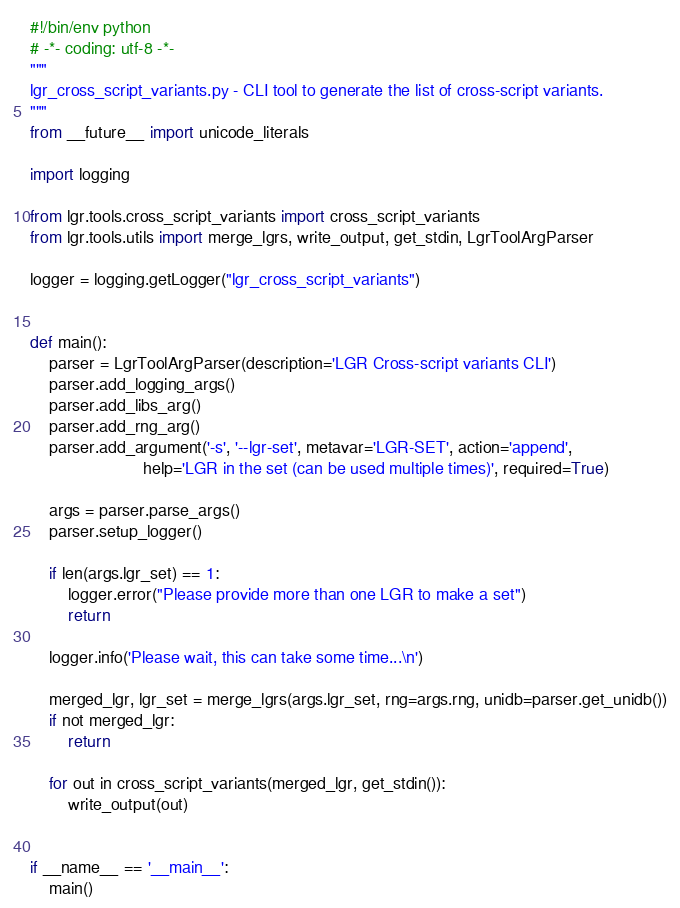<code> <loc_0><loc_0><loc_500><loc_500><_Python_>#!/bin/env python
# -*- coding: utf-8 -*-
"""
lgr_cross_script_variants.py - CLI tool to generate the list of cross-script variants.
"""
from __future__ import unicode_literals

import logging

from lgr.tools.cross_script_variants import cross_script_variants
from lgr.tools.utils import merge_lgrs, write_output, get_stdin, LgrToolArgParser

logger = logging.getLogger("lgr_cross_script_variants")


def main():
    parser = LgrToolArgParser(description='LGR Cross-script variants CLI')
    parser.add_logging_args()
    parser.add_libs_arg()
    parser.add_rng_arg()
    parser.add_argument('-s', '--lgr-set', metavar='LGR-SET', action='append',
                        help='LGR in the set (can be used multiple times)', required=True)

    args = parser.parse_args()
    parser.setup_logger()

    if len(args.lgr_set) == 1:
        logger.error("Please provide more than one LGR to make a set")
        return

    logger.info('Please wait, this can take some time...\n')

    merged_lgr, lgr_set = merge_lgrs(args.lgr_set, rng=args.rng, unidb=parser.get_unidb())
    if not merged_lgr:
        return

    for out in cross_script_variants(merged_lgr, get_stdin()):
        write_output(out)


if __name__ == '__main__':
    main()
</code> 